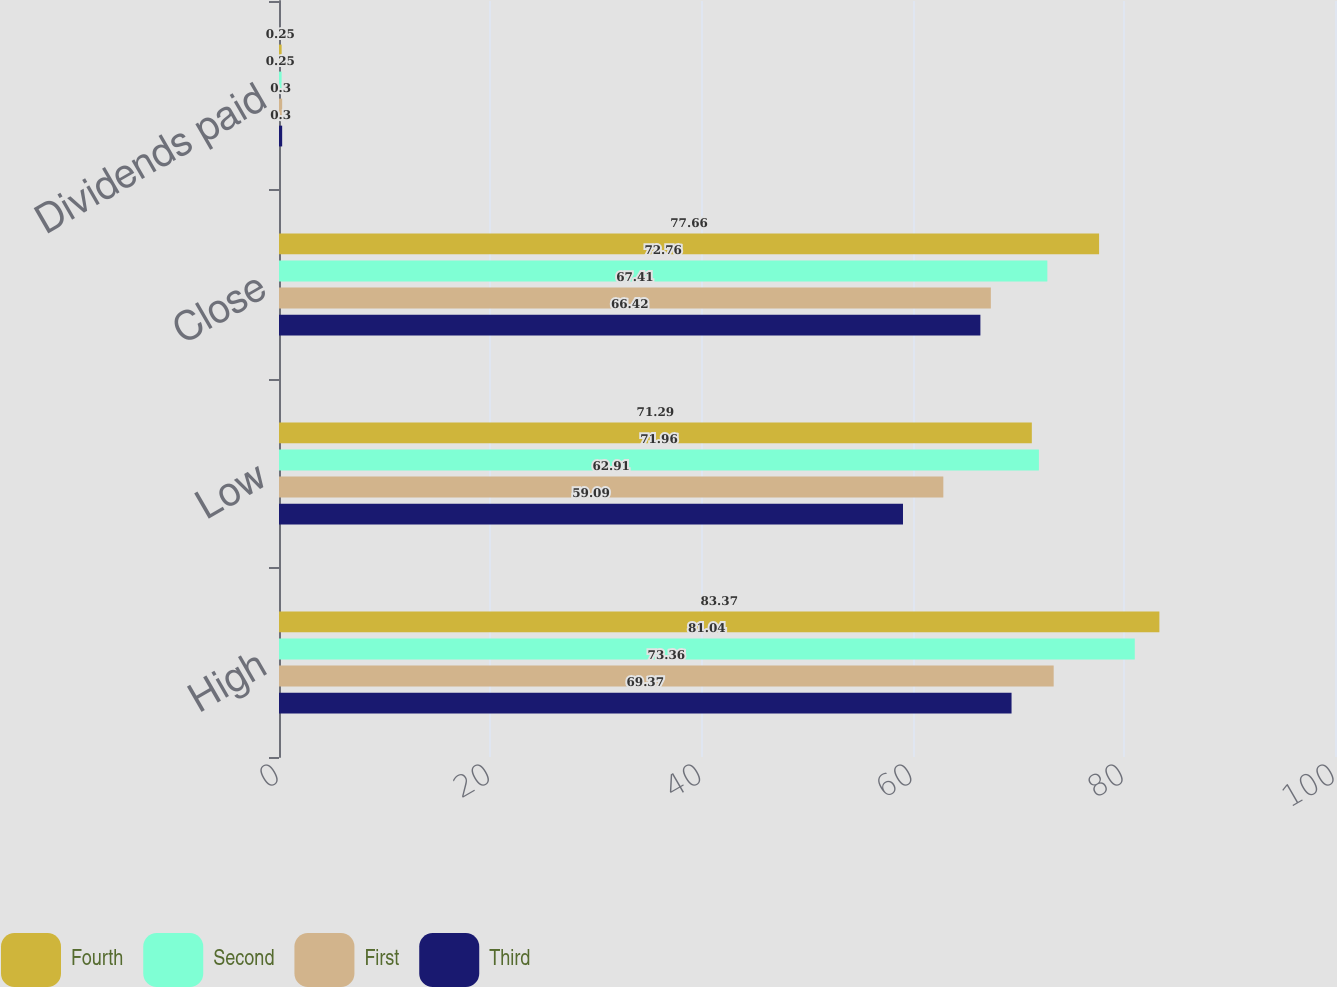Convert chart. <chart><loc_0><loc_0><loc_500><loc_500><stacked_bar_chart><ecel><fcel>High<fcel>Low<fcel>Close<fcel>Dividends paid<nl><fcel>Fourth<fcel>83.37<fcel>71.29<fcel>77.66<fcel>0.25<nl><fcel>Second<fcel>81.04<fcel>71.96<fcel>72.76<fcel>0.25<nl><fcel>First<fcel>73.36<fcel>62.91<fcel>67.41<fcel>0.3<nl><fcel>Third<fcel>69.37<fcel>59.09<fcel>66.42<fcel>0.3<nl></chart> 